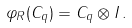Convert formula to latex. <formula><loc_0><loc_0><loc_500><loc_500>\varphi _ { R } ( C _ { q } ) = C _ { q } \otimes { I } \, .</formula> 